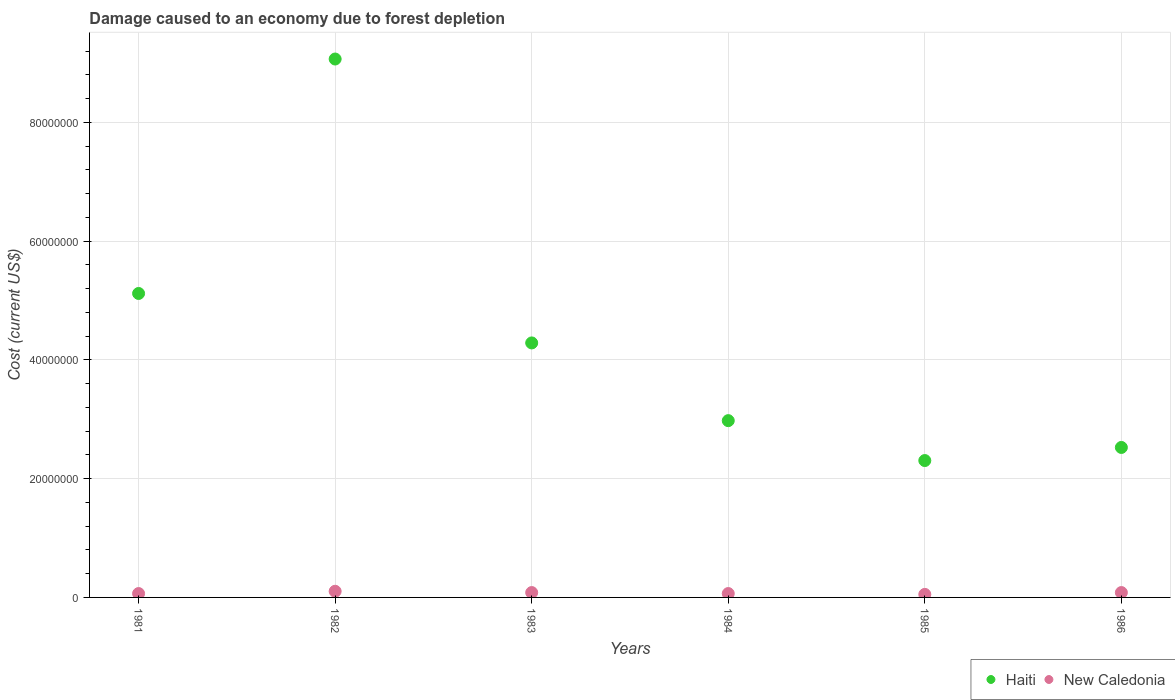What is the cost of damage caused due to forest depletion in Haiti in 1984?
Offer a terse response. 2.98e+07. Across all years, what is the maximum cost of damage caused due to forest depletion in New Caledonia?
Your answer should be very brief. 1.04e+06. Across all years, what is the minimum cost of damage caused due to forest depletion in New Caledonia?
Provide a succinct answer. 5.10e+05. In which year was the cost of damage caused due to forest depletion in New Caledonia minimum?
Your response must be concise. 1985. What is the total cost of damage caused due to forest depletion in New Caledonia in the graph?
Keep it short and to the point. 4.49e+06. What is the difference between the cost of damage caused due to forest depletion in New Caledonia in 1982 and that in 1983?
Your response must be concise. 2.17e+05. What is the difference between the cost of damage caused due to forest depletion in New Caledonia in 1983 and the cost of damage caused due to forest depletion in Haiti in 1982?
Give a very brief answer. -8.99e+07. What is the average cost of damage caused due to forest depletion in Haiti per year?
Your answer should be very brief. 4.38e+07. In the year 1982, what is the difference between the cost of damage caused due to forest depletion in New Caledonia and cost of damage caused due to forest depletion in Haiti?
Your answer should be compact. -8.97e+07. In how many years, is the cost of damage caused due to forest depletion in New Caledonia greater than 24000000 US$?
Your response must be concise. 0. What is the ratio of the cost of damage caused due to forest depletion in New Caledonia in 1983 to that in 1986?
Your answer should be compact. 1. Is the cost of damage caused due to forest depletion in Haiti in 1983 less than that in 1984?
Give a very brief answer. No. What is the difference between the highest and the second highest cost of damage caused due to forest depletion in Haiti?
Keep it short and to the point. 3.95e+07. What is the difference between the highest and the lowest cost of damage caused due to forest depletion in New Caledonia?
Offer a terse response. 5.26e+05. In how many years, is the cost of damage caused due to forest depletion in Haiti greater than the average cost of damage caused due to forest depletion in Haiti taken over all years?
Keep it short and to the point. 2. Does the cost of damage caused due to forest depletion in Haiti monotonically increase over the years?
Your answer should be compact. No. Is the cost of damage caused due to forest depletion in New Caledonia strictly less than the cost of damage caused due to forest depletion in Haiti over the years?
Make the answer very short. Yes. How many dotlines are there?
Give a very brief answer. 2. What is the difference between two consecutive major ticks on the Y-axis?
Ensure brevity in your answer.  2.00e+07. Are the values on the major ticks of Y-axis written in scientific E-notation?
Your answer should be compact. No. Does the graph contain any zero values?
Make the answer very short. No. Where does the legend appear in the graph?
Keep it short and to the point. Bottom right. How many legend labels are there?
Your answer should be very brief. 2. What is the title of the graph?
Provide a short and direct response. Damage caused to an economy due to forest depletion. Does "Turkmenistan" appear as one of the legend labels in the graph?
Your answer should be very brief. No. What is the label or title of the Y-axis?
Give a very brief answer. Cost (current US$). What is the Cost (current US$) of Haiti in 1981?
Provide a short and direct response. 5.12e+07. What is the Cost (current US$) in New Caledonia in 1981?
Offer a very short reply. 6.52e+05. What is the Cost (current US$) of Haiti in 1982?
Provide a succinct answer. 9.07e+07. What is the Cost (current US$) of New Caledonia in 1982?
Keep it short and to the point. 1.04e+06. What is the Cost (current US$) of Haiti in 1983?
Your response must be concise. 4.29e+07. What is the Cost (current US$) in New Caledonia in 1983?
Provide a succinct answer. 8.19e+05. What is the Cost (current US$) of Haiti in 1984?
Provide a succinct answer. 2.98e+07. What is the Cost (current US$) in New Caledonia in 1984?
Your answer should be compact. 6.53e+05. What is the Cost (current US$) of Haiti in 1985?
Ensure brevity in your answer.  2.31e+07. What is the Cost (current US$) in New Caledonia in 1985?
Your answer should be compact. 5.10e+05. What is the Cost (current US$) in Haiti in 1986?
Make the answer very short. 2.53e+07. What is the Cost (current US$) in New Caledonia in 1986?
Provide a succinct answer. 8.18e+05. Across all years, what is the maximum Cost (current US$) in Haiti?
Give a very brief answer. 9.07e+07. Across all years, what is the maximum Cost (current US$) of New Caledonia?
Your answer should be compact. 1.04e+06. Across all years, what is the minimum Cost (current US$) in Haiti?
Make the answer very short. 2.31e+07. Across all years, what is the minimum Cost (current US$) of New Caledonia?
Make the answer very short. 5.10e+05. What is the total Cost (current US$) in Haiti in the graph?
Offer a terse response. 2.63e+08. What is the total Cost (current US$) of New Caledonia in the graph?
Your answer should be very brief. 4.49e+06. What is the difference between the Cost (current US$) of Haiti in 1981 and that in 1982?
Your answer should be compact. -3.95e+07. What is the difference between the Cost (current US$) of New Caledonia in 1981 and that in 1982?
Your answer should be very brief. -3.84e+05. What is the difference between the Cost (current US$) of Haiti in 1981 and that in 1983?
Make the answer very short. 8.33e+06. What is the difference between the Cost (current US$) of New Caledonia in 1981 and that in 1983?
Keep it short and to the point. -1.67e+05. What is the difference between the Cost (current US$) of Haiti in 1981 and that in 1984?
Your answer should be very brief. 2.14e+07. What is the difference between the Cost (current US$) in New Caledonia in 1981 and that in 1984?
Provide a short and direct response. -970.05. What is the difference between the Cost (current US$) of Haiti in 1981 and that in 1985?
Make the answer very short. 2.81e+07. What is the difference between the Cost (current US$) of New Caledonia in 1981 and that in 1985?
Provide a succinct answer. 1.42e+05. What is the difference between the Cost (current US$) of Haiti in 1981 and that in 1986?
Make the answer very short. 2.59e+07. What is the difference between the Cost (current US$) in New Caledonia in 1981 and that in 1986?
Keep it short and to the point. -1.66e+05. What is the difference between the Cost (current US$) of Haiti in 1982 and that in 1983?
Offer a very short reply. 4.78e+07. What is the difference between the Cost (current US$) of New Caledonia in 1982 and that in 1983?
Ensure brevity in your answer.  2.17e+05. What is the difference between the Cost (current US$) in Haiti in 1982 and that in 1984?
Give a very brief answer. 6.09e+07. What is the difference between the Cost (current US$) in New Caledonia in 1982 and that in 1984?
Give a very brief answer. 3.83e+05. What is the difference between the Cost (current US$) of Haiti in 1982 and that in 1985?
Provide a succinct answer. 6.76e+07. What is the difference between the Cost (current US$) of New Caledonia in 1982 and that in 1985?
Make the answer very short. 5.26e+05. What is the difference between the Cost (current US$) of Haiti in 1982 and that in 1986?
Ensure brevity in your answer.  6.54e+07. What is the difference between the Cost (current US$) in New Caledonia in 1982 and that in 1986?
Provide a succinct answer. 2.18e+05. What is the difference between the Cost (current US$) in Haiti in 1983 and that in 1984?
Make the answer very short. 1.31e+07. What is the difference between the Cost (current US$) in New Caledonia in 1983 and that in 1984?
Your response must be concise. 1.66e+05. What is the difference between the Cost (current US$) of Haiti in 1983 and that in 1985?
Your answer should be very brief. 1.98e+07. What is the difference between the Cost (current US$) of New Caledonia in 1983 and that in 1985?
Keep it short and to the point. 3.09e+05. What is the difference between the Cost (current US$) of Haiti in 1983 and that in 1986?
Give a very brief answer. 1.76e+07. What is the difference between the Cost (current US$) in New Caledonia in 1983 and that in 1986?
Ensure brevity in your answer.  708.4. What is the difference between the Cost (current US$) of Haiti in 1984 and that in 1985?
Offer a very short reply. 6.72e+06. What is the difference between the Cost (current US$) of New Caledonia in 1984 and that in 1985?
Your response must be concise. 1.43e+05. What is the difference between the Cost (current US$) of Haiti in 1984 and that in 1986?
Offer a terse response. 4.51e+06. What is the difference between the Cost (current US$) in New Caledonia in 1984 and that in 1986?
Your answer should be very brief. -1.65e+05. What is the difference between the Cost (current US$) of Haiti in 1985 and that in 1986?
Make the answer very short. -2.21e+06. What is the difference between the Cost (current US$) of New Caledonia in 1985 and that in 1986?
Make the answer very short. -3.08e+05. What is the difference between the Cost (current US$) of Haiti in 1981 and the Cost (current US$) of New Caledonia in 1982?
Provide a succinct answer. 5.02e+07. What is the difference between the Cost (current US$) in Haiti in 1981 and the Cost (current US$) in New Caledonia in 1983?
Your answer should be compact. 5.04e+07. What is the difference between the Cost (current US$) in Haiti in 1981 and the Cost (current US$) in New Caledonia in 1984?
Provide a short and direct response. 5.05e+07. What is the difference between the Cost (current US$) in Haiti in 1981 and the Cost (current US$) in New Caledonia in 1985?
Your answer should be very brief. 5.07e+07. What is the difference between the Cost (current US$) in Haiti in 1981 and the Cost (current US$) in New Caledonia in 1986?
Give a very brief answer. 5.04e+07. What is the difference between the Cost (current US$) of Haiti in 1982 and the Cost (current US$) of New Caledonia in 1983?
Your response must be concise. 8.99e+07. What is the difference between the Cost (current US$) in Haiti in 1982 and the Cost (current US$) in New Caledonia in 1984?
Your response must be concise. 9.00e+07. What is the difference between the Cost (current US$) of Haiti in 1982 and the Cost (current US$) of New Caledonia in 1985?
Your answer should be very brief. 9.02e+07. What is the difference between the Cost (current US$) in Haiti in 1982 and the Cost (current US$) in New Caledonia in 1986?
Offer a terse response. 8.99e+07. What is the difference between the Cost (current US$) in Haiti in 1983 and the Cost (current US$) in New Caledonia in 1984?
Keep it short and to the point. 4.22e+07. What is the difference between the Cost (current US$) in Haiti in 1983 and the Cost (current US$) in New Caledonia in 1985?
Provide a succinct answer. 4.24e+07. What is the difference between the Cost (current US$) in Haiti in 1983 and the Cost (current US$) in New Caledonia in 1986?
Provide a succinct answer. 4.20e+07. What is the difference between the Cost (current US$) in Haiti in 1984 and the Cost (current US$) in New Caledonia in 1985?
Give a very brief answer. 2.93e+07. What is the difference between the Cost (current US$) of Haiti in 1984 and the Cost (current US$) of New Caledonia in 1986?
Provide a short and direct response. 2.90e+07. What is the difference between the Cost (current US$) in Haiti in 1985 and the Cost (current US$) in New Caledonia in 1986?
Provide a short and direct response. 2.22e+07. What is the average Cost (current US$) of Haiti per year?
Give a very brief answer. 4.38e+07. What is the average Cost (current US$) in New Caledonia per year?
Offer a terse response. 7.48e+05. In the year 1981, what is the difference between the Cost (current US$) of Haiti and Cost (current US$) of New Caledonia?
Ensure brevity in your answer.  5.05e+07. In the year 1982, what is the difference between the Cost (current US$) in Haiti and Cost (current US$) in New Caledonia?
Keep it short and to the point. 8.97e+07. In the year 1983, what is the difference between the Cost (current US$) of Haiti and Cost (current US$) of New Caledonia?
Make the answer very short. 4.20e+07. In the year 1984, what is the difference between the Cost (current US$) in Haiti and Cost (current US$) in New Caledonia?
Ensure brevity in your answer.  2.91e+07. In the year 1985, what is the difference between the Cost (current US$) of Haiti and Cost (current US$) of New Caledonia?
Ensure brevity in your answer.  2.25e+07. In the year 1986, what is the difference between the Cost (current US$) of Haiti and Cost (current US$) of New Caledonia?
Offer a terse response. 2.44e+07. What is the ratio of the Cost (current US$) of Haiti in 1981 to that in 1982?
Make the answer very short. 0.56. What is the ratio of the Cost (current US$) in New Caledonia in 1981 to that in 1982?
Offer a very short reply. 0.63. What is the ratio of the Cost (current US$) in Haiti in 1981 to that in 1983?
Offer a terse response. 1.19. What is the ratio of the Cost (current US$) of New Caledonia in 1981 to that in 1983?
Your answer should be very brief. 0.8. What is the ratio of the Cost (current US$) of Haiti in 1981 to that in 1984?
Ensure brevity in your answer.  1.72. What is the ratio of the Cost (current US$) in Haiti in 1981 to that in 1985?
Offer a very short reply. 2.22. What is the ratio of the Cost (current US$) in New Caledonia in 1981 to that in 1985?
Offer a terse response. 1.28. What is the ratio of the Cost (current US$) in Haiti in 1981 to that in 1986?
Give a very brief answer. 2.03. What is the ratio of the Cost (current US$) of New Caledonia in 1981 to that in 1986?
Give a very brief answer. 0.8. What is the ratio of the Cost (current US$) in Haiti in 1982 to that in 1983?
Keep it short and to the point. 2.12. What is the ratio of the Cost (current US$) in New Caledonia in 1982 to that in 1983?
Provide a short and direct response. 1.27. What is the ratio of the Cost (current US$) in Haiti in 1982 to that in 1984?
Keep it short and to the point. 3.05. What is the ratio of the Cost (current US$) of New Caledonia in 1982 to that in 1984?
Provide a short and direct response. 1.59. What is the ratio of the Cost (current US$) of Haiti in 1982 to that in 1985?
Provide a succinct answer. 3.93. What is the ratio of the Cost (current US$) in New Caledonia in 1982 to that in 1985?
Provide a succinct answer. 2.03. What is the ratio of the Cost (current US$) in Haiti in 1982 to that in 1986?
Offer a terse response. 3.59. What is the ratio of the Cost (current US$) in New Caledonia in 1982 to that in 1986?
Make the answer very short. 1.27. What is the ratio of the Cost (current US$) of Haiti in 1983 to that in 1984?
Your response must be concise. 1.44. What is the ratio of the Cost (current US$) in New Caledonia in 1983 to that in 1984?
Provide a short and direct response. 1.25. What is the ratio of the Cost (current US$) in Haiti in 1983 to that in 1985?
Provide a short and direct response. 1.86. What is the ratio of the Cost (current US$) in New Caledonia in 1983 to that in 1985?
Provide a succinct answer. 1.61. What is the ratio of the Cost (current US$) of Haiti in 1983 to that in 1986?
Your answer should be compact. 1.7. What is the ratio of the Cost (current US$) in New Caledonia in 1983 to that in 1986?
Provide a succinct answer. 1. What is the ratio of the Cost (current US$) in Haiti in 1984 to that in 1985?
Ensure brevity in your answer.  1.29. What is the ratio of the Cost (current US$) in New Caledonia in 1984 to that in 1985?
Give a very brief answer. 1.28. What is the ratio of the Cost (current US$) in Haiti in 1984 to that in 1986?
Give a very brief answer. 1.18. What is the ratio of the Cost (current US$) of New Caledonia in 1984 to that in 1986?
Your answer should be very brief. 0.8. What is the ratio of the Cost (current US$) in Haiti in 1985 to that in 1986?
Make the answer very short. 0.91. What is the ratio of the Cost (current US$) in New Caledonia in 1985 to that in 1986?
Ensure brevity in your answer.  0.62. What is the difference between the highest and the second highest Cost (current US$) in Haiti?
Offer a very short reply. 3.95e+07. What is the difference between the highest and the second highest Cost (current US$) in New Caledonia?
Make the answer very short. 2.17e+05. What is the difference between the highest and the lowest Cost (current US$) of Haiti?
Keep it short and to the point. 6.76e+07. What is the difference between the highest and the lowest Cost (current US$) in New Caledonia?
Provide a succinct answer. 5.26e+05. 